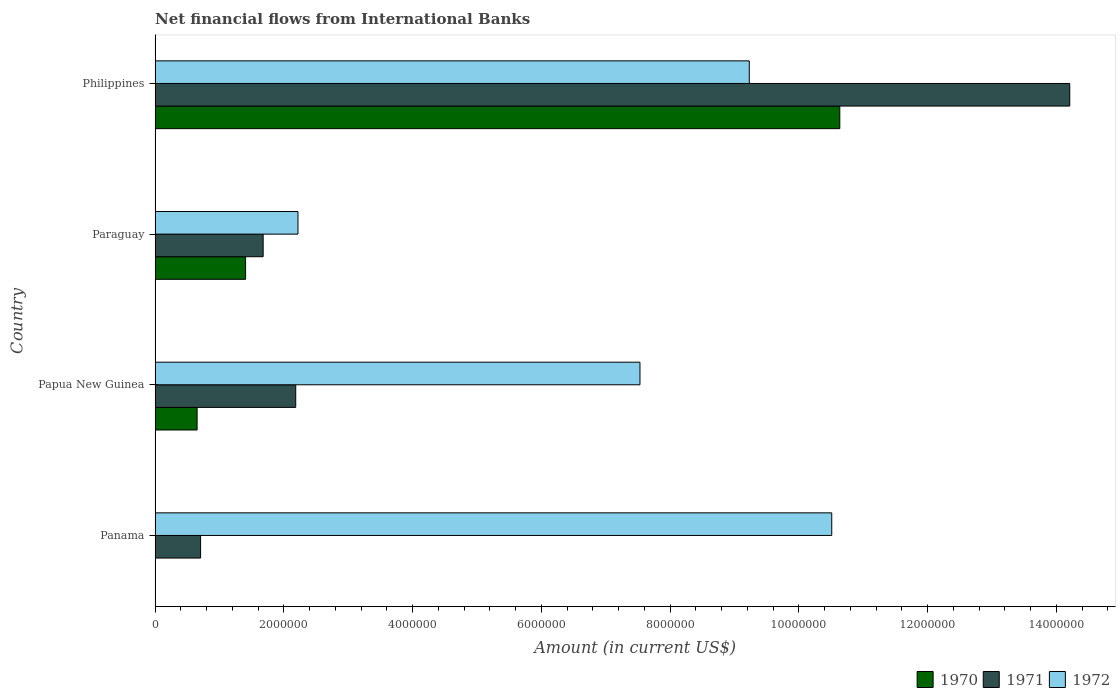How many different coloured bars are there?
Offer a very short reply. 3. Are the number of bars on each tick of the Y-axis equal?
Provide a short and direct response. No. How many bars are there on the 2nd tick from the top?
Make the answer very short. 3. How many bars are there on the 2nd tick from the bottom?
Your answer should be very brief. 3. What is the label of the 4th group of bars from the top?
Give a very brief answer. Panama. What is the net financial aid flows in 1972 in Panama?
Ensure brevity in your answer.  1.05e+07. Across all countries, what is the maximum net financial aid flows in 1971?
Offer a very short reply. 1.42e+07. Across all countries, what is the minimum net financial aid flows in 1971?
Keep it short and to the point. 7.07e+05. In which country was the net financial aid flows in 1970 maximum?
Ensure brevity in your answer.  Philippines. What is the total net financial aid flows in 1972 in the graph?
Ensure brevity in your answer.  2.95e+07. What is the difference between the net financial aid flows in 1970 in Paraguay and that in Philippines?
Make the answer very short. -9.23e+06. What is the difference between the net financial aid flows in 1970 in Papua New Guinea and the net financial aid flows in 1971 in Paraguay?
Offer a terse response. -1.03e+06. What is the average net financial aid flows in 1971 per country?
Offer a very short reply. 4.69e+06. What is the difference between the net financial aid flows in 1972 and net financial aid flows in 1971 in Philippines?
Your answer should be compact. -4.98e+06. In how many countries, is the net financial aid flows in 1970 greater than 9200000 US$?
Keep it short and to the point. 1. What is the ratio of the net financial aid flows in 1970 in Paraguay to that in Philippines?
Give a very brief answer. 0.13. Is the net financial aid flows in 1972 in Panama less than that in Philippines?
Keep it short and to the point. No. Is the difference between the net financial aid flows in 1972 in Papua New Guinea and Paraguay greater than the difference between the net financial aid flows in 1971 in Papua New Guinea and Paraguay?
Your answer should be very brief. Yes. What is the difference between the highest and the second highest net financial aid flows in 1971?
Your answer should be compact. 1.20e+07. What is the difference between the highest and the lowest net financial aid flows in 1971?
Keep it short and to the point. 1.35e+07. In how many countries, is the net financial aid flows in 1972 greater than the average net financial aid flows in 1972 taken over all countries?
Offer a terse response. 3. How many bars are there?
Make the answer very short. 11. Are all the bars in the graph horizontal?
Your answer should be compact. Yes. How many countries are there in the graph?
Make the answer very short. 4. What is the difference between two consecutive major ticks on the X-axis?
Your answer should be compact. 2.00e+06. Does the graph contain any zero values?
Offer a terse response. Yes. Does the graph contain grids?
Your response must be concise. No. How are the legend labels stacked?
Your answer should be very brief. Horizontal. What is the title of the graph?
Offer a very short reply. Net financial flows from International Banks. What is the Amount (in current US$) in 1971 in Panama?
Make the answer very short. 7.07e+05. What is the Amount (in current US$) of 1972 in Panama?
Provide a succinct answer. 1.05e+07. What is the Amount (in current US$) in 1970 in Papua New Guinea?
Make the answer very short. 6.53e+05. What is the Amount (in current US$) of 1971 in Papua New Guinea?
Provide a succinct answer. 2.18e+06. What is the Amount (in current US$) of 1972 in Papua New Guinea?
Offer a very short reply. 7.53e+06. What is the Amount (in current US$) in 1970 in Paraguay?
Provide a succinct answer. 1.41e+06. What is the Amount (in current US$) of 1971 in Paraguay?
Give a very brief answer. 1.68e+06. What is the Amount (in current US$) of 1972 in Paraguay?
Keep it short and to the point. 2.22e+06. What is the Amount (in current US$) of 1970 in Philippines?
Keep it short and to the point. 1.06e+07. What is the Amount (in current US$) of 1971 in Philippines?
Your response must be concise. 1.42e+07. What is the Amount (in current US$) in 1972 in Philippines?
Ensure brevity in your answer.  9.23e+06. Across all countries, what is the maximum Amount (in current US$) in 1970?
Your answer should be compact. 1.06e+07. Across all countries, what is the maximum Amount (in current US$) in 1971?
Your answer should be compact. 1.42e+07. Across all countries, what is the maximum Amount (in current US$) of 1972?
Your response must be concise. 1.05e+07. Across all countries, what is the minimum Amount (in current US$) in 1970?
Offer a very short reply. 0. Across all countries, what is the minimum Amount (in current US$) of 1971?
Your answer should be compact. 7.07e+05. Across all countries, what is the minimum Amount (in current US$) of 1972?
Offer a very short reply. 2.22e+06. What is the total Amount (in current US$) of 1970 in the graph?
Keep it short and to the point. 1.27e+07. What is the total Amount (in current US$) of 1971 in the graph?
Your response must be concise. 1.88e+07. What is the total Amount (in current US$) of 1972 in the graph?
Your answer should be very brief. 2.95e+07. What is the difference between the Amount (in current US$) in 1971 in Panama and that in Papua New Guinea?
Give a very brief answer. -1.48e+06. What is the difference between the Amount (in current US$) in 1972 in Panama and that in Papua New Guinea?
Give a very brief answer. 2.98e+06. What is the difference between the Amount (in current US$) in 1971 in Panama and that in Paraguay?
Provide a short and direct response. -9.72e+05. What is the difference between the Amount (in current US$) of 1972 in Panama and that in Paraguay?
Ensure brevity in your answer.  8.29e+06. What is the difference between the Amount (in current US$) of 1971 in Panama and that in Philippines?
Offer a very short reply. -1.35e+07. What is the difference between the Amount (in current US$) in 1972 in Panama and that in Philippines?
Provide a short and direct response. 1.28e+06. What is the difference between the Amount (in current US$) of 1970 in Papua New Guinea and that in Paraguay?
Your answer should be compact. -7.53e+05. What is the difference between the Amount (in current US$) in 1971 in Papua New Guinea and that in Paraguay?
Your response must be concise. 5.06e+05. What is the difference between the Amount (in current US$) of 1972 in Papua New Guinea and that in Paraguay?
Your response must be concise. 5.31e+06. What is the difference between the Amount (in current US$) in 1970 in Papua New Guinea and that in Philippines?
Provide a short and direct response. -9.98e+06. What is the difference between the Amount (in current US$) of 1971 in Papua New Guinea and that in Philippines?
Your response must be concise. -1.20e+07. What is the difference between the Amount (in current US$) in 1972 in Papua New Guinea and that in Philippines?
Keep it short and to the point. -1.70e+06. What is the difference between the Amount (in current US$) in 1970 in Paraguay and that in Philippines?
Make the answer very short. -9.23e+06. What is the difference between the Amount (in current US$) in 1971 in Paraguay and that in Philippines?
Your response must be concise. -1.25e+07. What is the difference between the Amount (in current US$) of 1972 in Paraguay and that in Philippines?
Make the answer very short. -7.01e+06. What is the difference between the Amount (in current US$) of 1971 in Panama and the Amount (in current US$) of 1972 in Papua New Guinea?
Offer a terse response. -6.82e+06. What is the difference between the Amount (in current US$) in 1971 in Panama and the Amount (in current US$) in 1972 in Paraguay?
Give a very brief answer. -1.51e+06. What is the difference between the Amount (in current US$) in 1971 in Panama and the Amount (in current US$) in 1972 in Philippines?
Ensure brevity in your answer.  -8.52e+06. What is the difference between the Amount (in current US$) in 1970 in Papua New Guinea and the Amount (in current US$) in 1971 in Paraguay?
Make the answer very short. -1.03e+06. What is the difference between the Amount (in current US$) in 1970 in Papua New Guinea and the Amount (in current US$) in 1972 in Paraguay?
Ensure brevity in your answer.  -1.57e+06. What is the difference between the Amount (in current US$) in 1971 in Papua New Guinea and the Amount (in current US$) in 1972 in Paraguay?
Offer a very short reply. -3.50e+04. What is the difference between the Amount (in current US$) in 1970 in Papua New Guinea and the Amount (in current US$) in 1971 in Philippines?
Make the answer very short. -1.36e+07. What is the difference between the Amount (in current US$) of 1970 in Papua New Guinea and the Amount (in current US$) of 1972 in Philippines?
Give a very brief answer. -8.58e+06. What is the difference between the Amount (in current US$) in 1971 in Papua New Guinea and the Amount (in current US$) in 1972 in Philippines?
Your answer should be compact. -7.04e+06. What is the difference between the Amount (in current US$) of 1970 in Paraguay and the Amount (in current US$) of 1971 in Philippines?
Keep it short and to the point. -1.28e+07. What is the difference between the Amount (in current US$) in 1970 in Paraguay and the Amount (in current US$) in 1972 in Philippines?
Your answer should be compact. -7.82e+06. What is the difference between the Amount (in current US$) in 1971 in Paraguay and the Amount (in current US$) in 1972 in Philippines?
Make the answer very short. -7.55e+06. What is the average Amount (in current US$) of 1970 per country?
Your response must be concise. 3.17e+06. What is the average Amount (in current US$) in 1971 per country?
Your answer should be very brief. 4.69e+06. What is the average Amount (in current US$) of 1972 per country?
Your answer should be compact. 7.37e+06. What is the difference between the Amount (in current US$) of 1971 and Amount (in current US$) of 1972 in Panama?
Your response must be concise. -9.80e+06. What is the difference between the Amount (in current US$) of 1970 and Amount (in current US$) of 1971 in Papua New Guinea?
Make the answer very short. -1.53e+06. What is the difference between the Amount (in current US$) of 1970 and Amount (in current US$) of 1972 in Papua New Guinea?
Provide a succinct answer. -6.88e+06. What is the difference between the Amount (in current US$) of 1971 and Amount (in current US$) of 1972 in Papua New Guinea?
Your answer should be very brief. -5.35e+06. What is the difference between the Amount (in current US$) of 1970 and Amount (in current US$) of 1971 in Paraguay?
Provide a succinct answer. -2.73e+05. What is the difference between the Amount (in current US$) of 1970 and Amount (in current US$) of 1972 in Paraguay?
Offer a very short reply. -8.14e+05. What is the difference between the Amount (in current US$) in 1971 and Amount (in current US$) in 1972 in Paraguay?
Your response must be concise. -5.41e+05. What is the difference between the Amount (in current US$) in 1970 and Amount (in current US$) in 1971 in Philippines?
Provide a short and direct response. -3.57e+06. What is the difference between the Amount (in current US$) of 1970 and Amount (in current US$) of 1972 in Philippines?
Offer a terse response. 1.41e+06. What is the difference between the Amount (in current US$) in 1971 and Amount (in current US$) in 1972 in Philippines?
Offer a terse response. 4.98e+06. What is the ratio of the Amount (in current US$) in 1971 in Panama to that in Papua New Guinea?
Make the answer very short. 0.32. What is the ratio of the Amount (in current US$) in 1972 in Panama to that in Papua New Guinea?
Ensure brevity in your answer.  1.4. What is the ratio of the Amount (in current US$) of 1971 in Panama to that in Paraguay?
Keep it short and to the point. 0.42. What is the ratio of the Amount (in current US$) in 1972 in Panama to that in Paraguay?
Provide a succinct answer. 4.73. What is the ratio of the Amount (in current US$) in 1971 in Panama to that in Philippines?
Your answer should be compact. 0.05. What is the ratio of the Amount (in current US$) of 1972 in Panama to that in Philippines?
Keep it short and to the point. 1.14. What is the ratio of the Amount (in current US$) in 1970 in Papua New Guinea to that in Paraguay?
Provide a succinct answer. 0.46. What is the ratio of the Amount (in current US$) of 1971 in Papua New Guinea to that in Paraguay?
Keep it short and to the point. 1.3. What is the ratio of the Amount (in current US$) of 1972 in Papua New Guinea to that in Paraguay?
Your answer should be compact. 3.39. What is the ratio of the Amount (in current US$) in 1970 in Papua New Guinea to that in Philippines?
Ensure brevity in your answer.  0.06. What is the ratio of the Amount (in current US$) of 1971 in Papua New Guinea to that in Philippines?
Ensure brevity in your answer.  0.15. What is the ratio of the Amount (in current US$) in 1972 in Papua New Guinea to that in Philippines?
Your response must be concise. 0.82. What is the ratio of the Amount (in current US$) of 1970 in Paraguay to that in Philippines?
Your response must be concise. 0.13. What is the ratio of the Amount (in current US$) of 1971 in Paraguay to that in Philippines?
Provide a succinct answer. 0.12. What is the ratio of the Amount (in current US$) in 1972 in Paraguay to that in Philippines?
Your response must be concise. 0.24. What is the difference between the highest and the second highest Amount (in current US$) of 1970?
Keep it short and to the point. 9.23e+06. What is the difference between the highest and the second highest Amount (in current US$) in 1971?
Provide a succinct answer. 1.20e+07. What is the difference between the highest and the second highest Amount (in current US$) in 1972?
Your response must be concise. 1.28e+06. What is the difference between the highest and the lowest Amount (in current US$) in 1970?
Your answer should be very brief. 1.06e+07. What is the difference between the highest and the lowest Amount (in current US$) of 1971?
Offer a very short reply. 1.35e+07. What is the difference between the highest and the lowest Amount (in current US$) in 1972?
Your answer should be compact. 8.29e+06. 